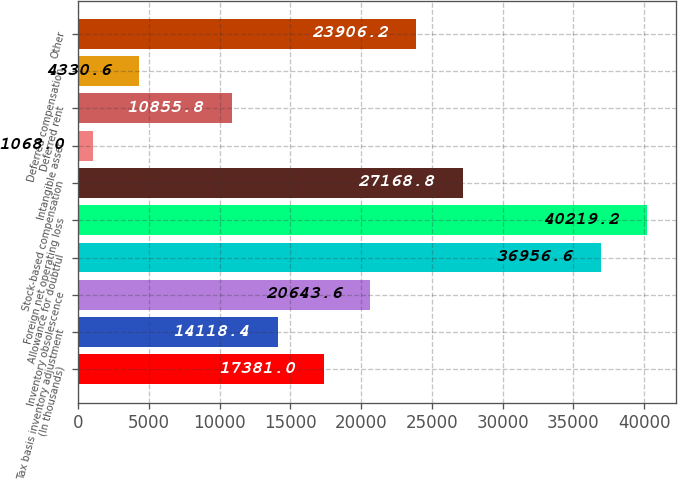Convert chart. <chart><loc_0><loc_0><loc_500><loc_500><bar_chart><fcel>(In thousands)<fcel>Tax basis inventory adjustment<fcel>Inventory obsolescence<fcel>Allowance for doubtful<fcel>Foreign net operating loss<fcel>Stock-based compensation<fcel>Intangible asset<fcel>Deferred rent<fcel>Deferred compensation<fcel>Other<nl><fcel>17381<fcel>14118.4<fcel>20643.6<fcel>36956.6<fcel>40219.2<fcel>27168.8<fcel>1068<fcel>10855.8<fcel>4330.6<fcel>23906.2<nl></chart> 